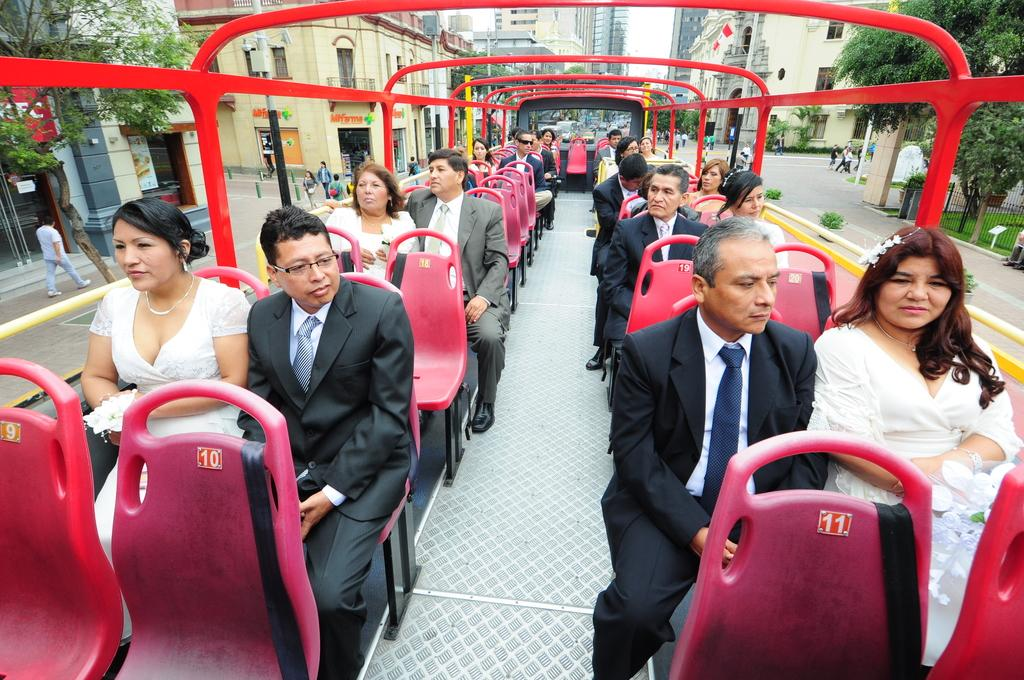<image>
Present a compact description of the photo's key features. People in suits and dresses on a bus in front of a Mifarma store. 